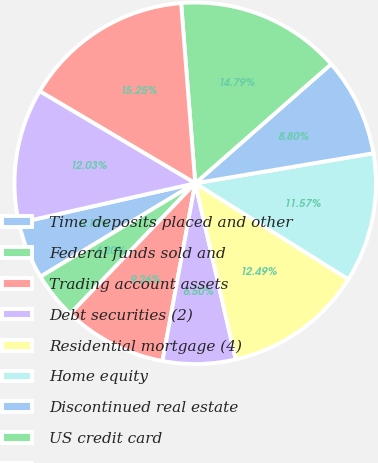Convert chart. <chart><loc_0><loc_0><loc_500><loc_500><pie_chart><fcel>Time deposits placed and other<fcel>Federal funds sold and<fcel>Trading account assets<fcel>Debt securities (2)<fcel>Residential mortgage (4)<fcel>Home equity<fcel>Discontinued real estate<fcel>US credit card<fcel>Non-US credit card<fcel>Direct/Indirect consumer (5)<nl><fcel>5.12%<fcel>4.2%<fcel>9.26%<fcel>6.5%<fcel>12.49%<fcel>11.57%<fcel>8.8%<fcel>14.79%<fcel>15.25%<fcel>12.03%<nl></chart> 